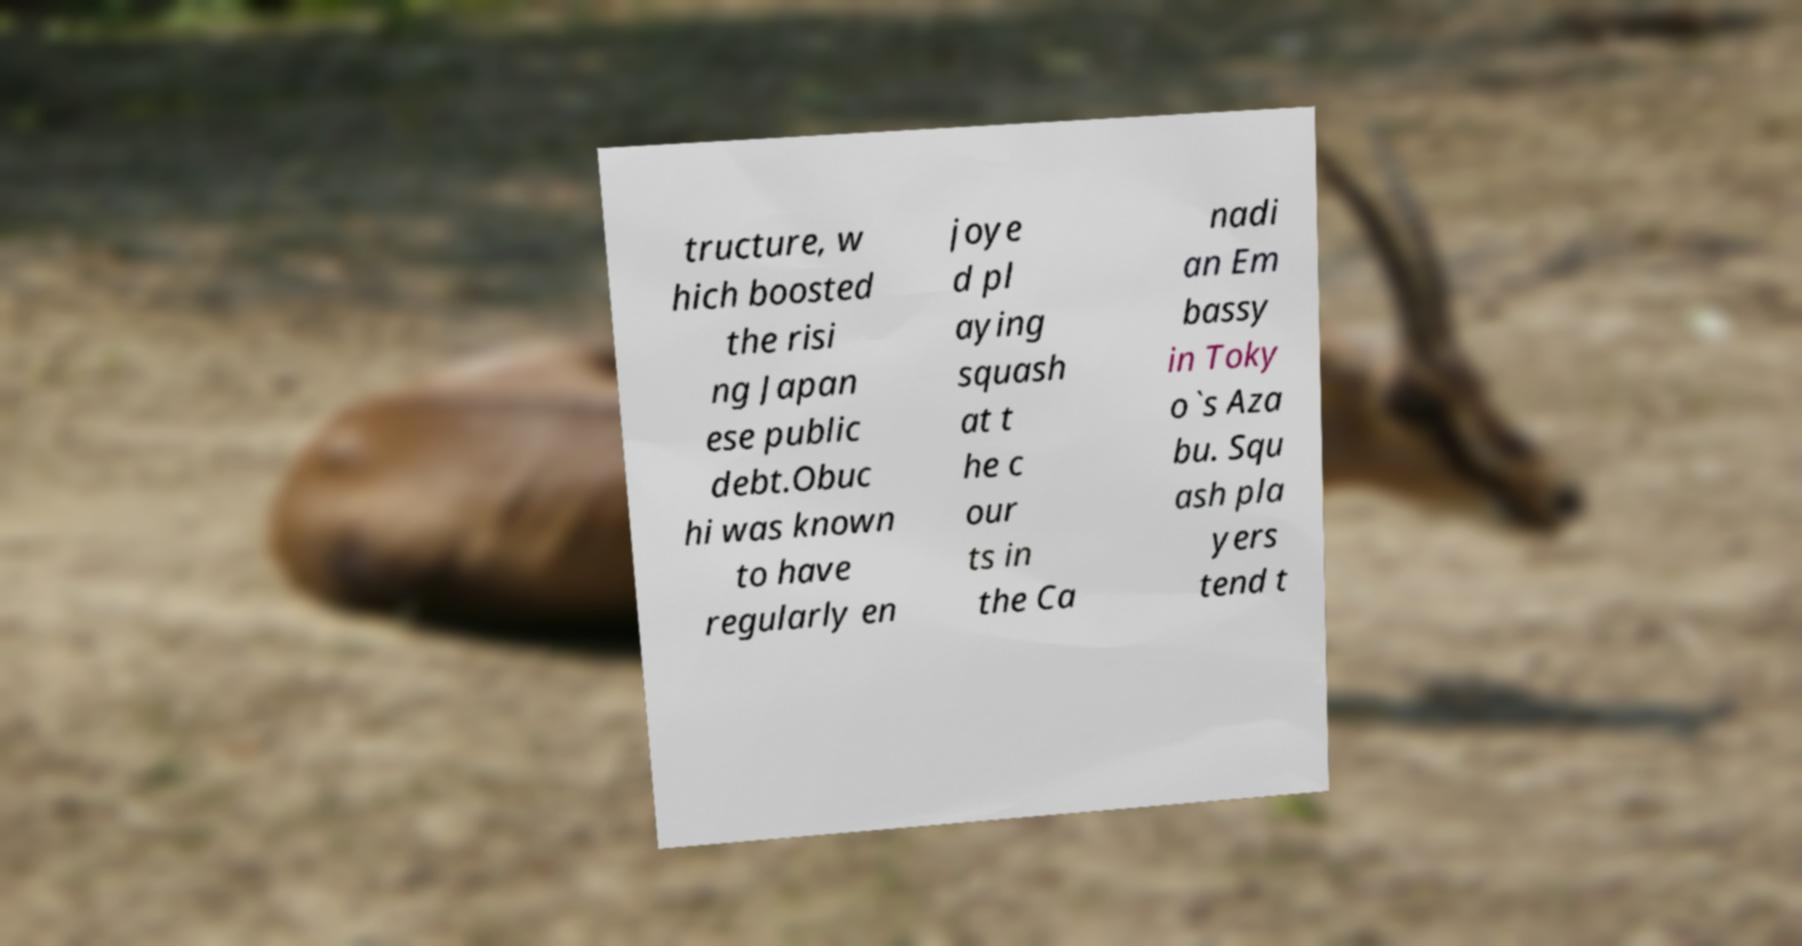There's text embedded in this image that I need extracted. Can you transcribe it verbatim? tructure, w hich boosted the risi ng Japan ese public debt.Obuc hi was known to have regularly en joye d pl aying squash at t he c our ts in the Ca nadi an Em bassy in Toky o`s Aza bu. Squ ash pla yers tend t 